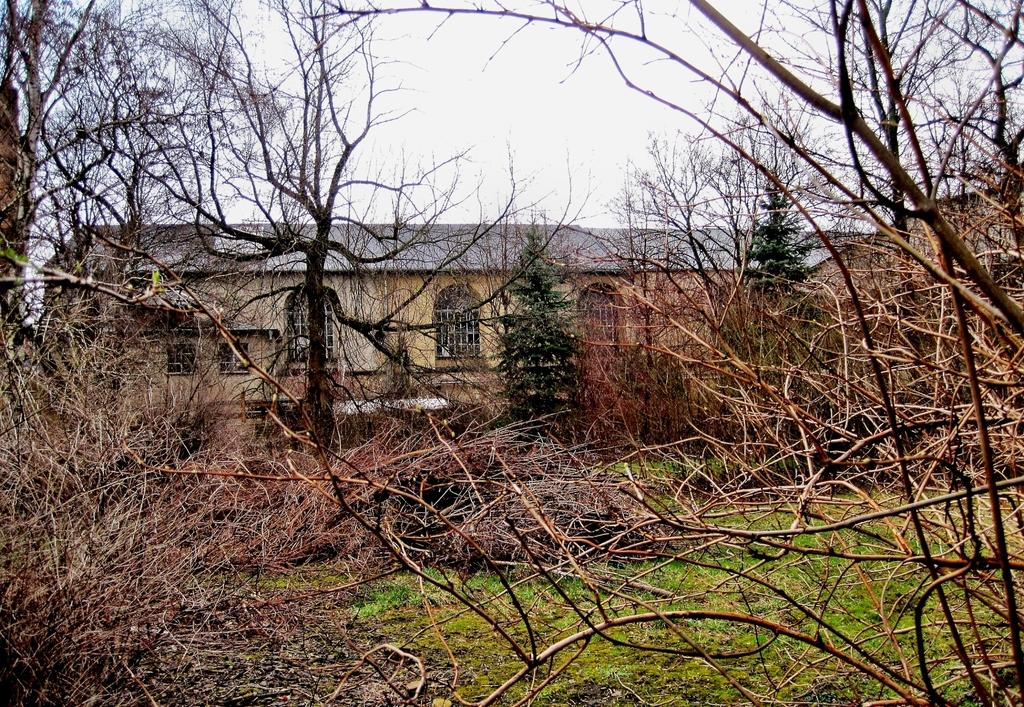What type of vegetation can be seen in the image? There are trees and grass in the image. What is located behind the trees in the image? There is a building behind the trees. What can be seen in the sky in the image? There are clouds visible in the sky. What part of the natural environment is visible in the image? The sky is visible in the image. Can you see a giraffe walking across the bridge in the image? There is no bridge or giraffe present in the image. 